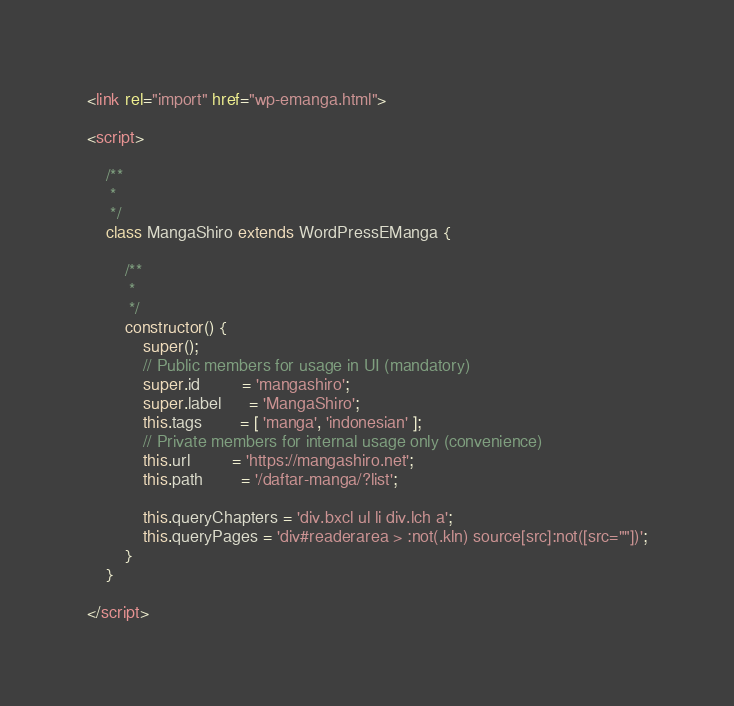<code> <loc_0><loc_0><loc_500><loc_500><_HTML_><link rel="import" href="wp-emanga.html">

<script>

    /**
     * 
     */
    class MangaShiro extends WordPressEManga {

        /**
         *
         */
        constructor() {
            super();
            // Public members for usage in UI (mandatory)
            super.id         = 'mangashiro';
            super.label      = 'MangaShiro';
            this.tags        = [ 'manga', 'indonesian' ];
            // Private members for internal usage only (convenience)
            this.url         = 'https://mangashiro.net';
            this.path        = '/daftar-manga/?list';

            this.queryChapters = 'div.bxcl ul li div.lch a';
            this.queryPages = 'div#readerarea > :not(.kln) source[src]:not([src=""])';
        }
    }

</script></code> 